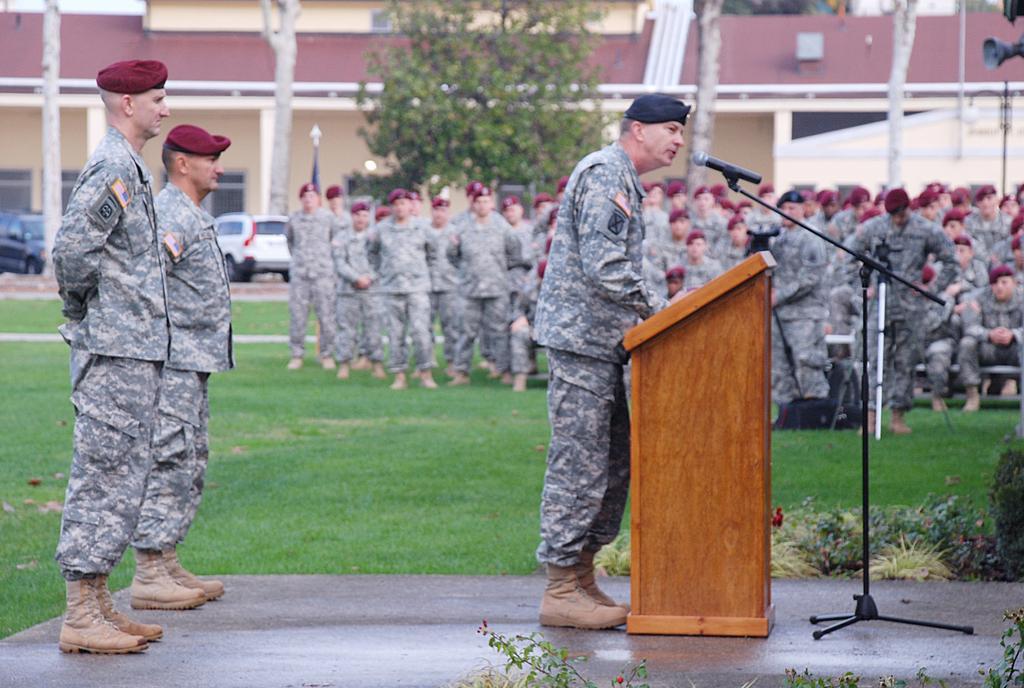In one or two sentences, can you explain what this image depicts? As we can see in the image there are group of people wearing army dress. the man over here is talking on mic. There is grass, cats, tree and a building. 